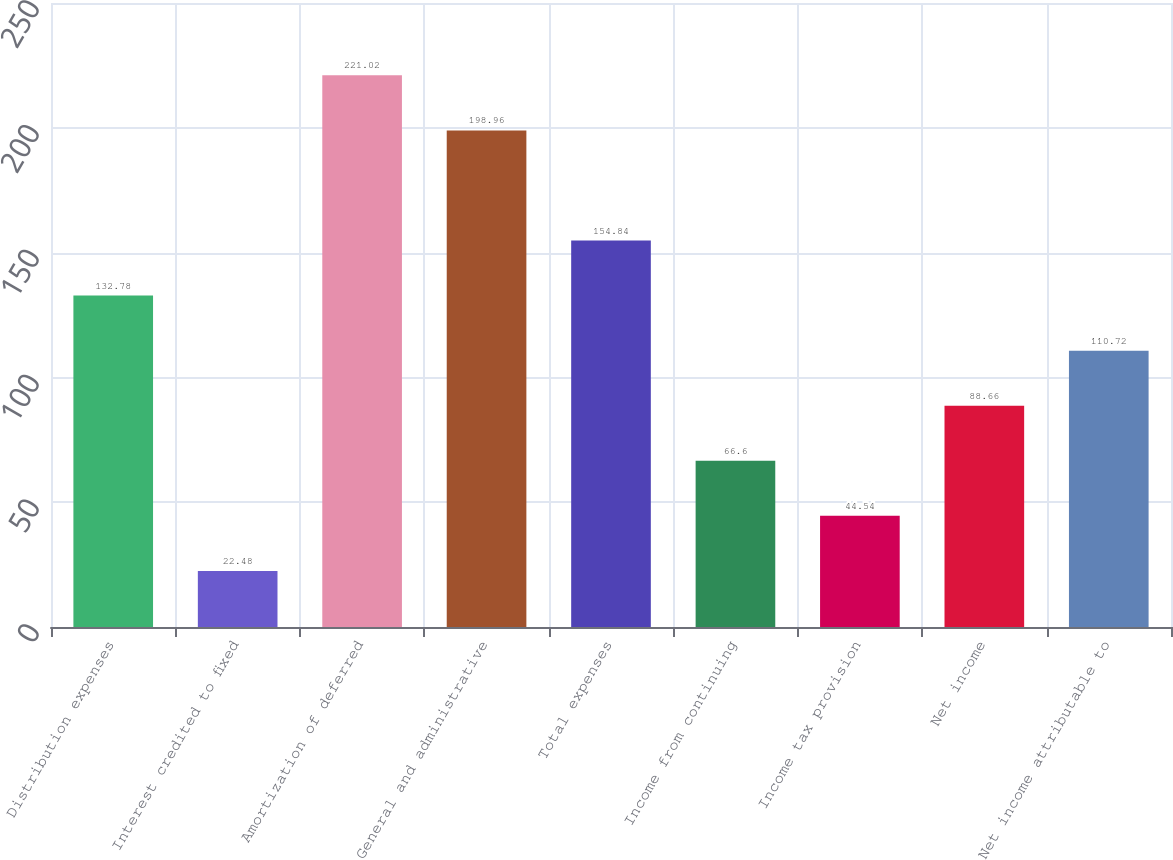Convert chart. <chart><loc_0><loc_0><loc_500><loc_500><bar_chart><fcel>Distribution expenses<fcel>Interest credited to fixed<fcel>Amortization of deferred<fcel>General and administrative<fcel>Total expenses<fcel>Income from continuing<fcel>Income tax provision<fcel>Net income<fcel>Net income attributable to<nl><fcel>132.78<fcel>22.48<fcel>221.02<fcel>198.96<fcel>154.84<fcel>66.6<fcel>44.54<fcel>88.66<fcel>110.72<nl></chart> 